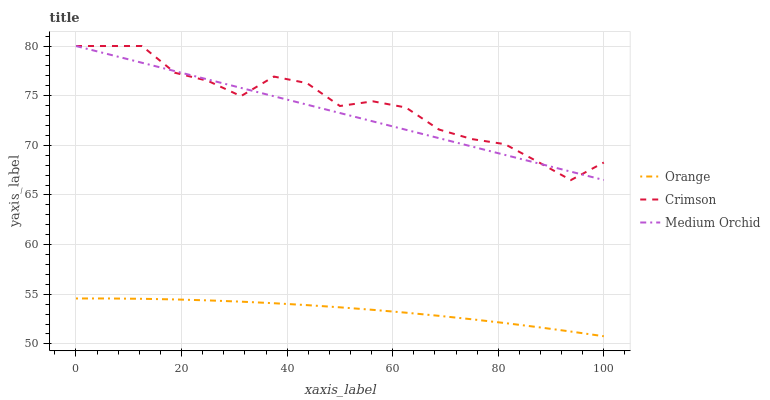Does Orange have the minimum area under the curve?
Answer yes or no. Yes. Does Crimson have the maximum area under the curve?
Answer yes or no. Yes. Does Medium Orchid have the minimum area under the curve?
Answer yes or no. No. Does Medium Orchid have the maximum area under the curve?
Answer yes or no. No. Is Medium Orchid the smoothest?
Answer yes or no. Yes. Is Crimson the roughest?
Answer yes or no. Yes. Is Crimson the smoothest?
Answer yes or no. No. Is Medium Orchid the roughest?
Answer yes or no. No. Does Orange have the lowest value?
Answer yes or no. Yes. Does Crimson have the lowest value?
Answer yes or no. No. Does Medium Orchid have the highest value?
Answer yes or no. Yes. Is Orange less than Medium Orchid?
Answer yes or no. Yes. Is Medium Orchid greater than Orange?
Answer yes or no. Yes. Does Crimson intersect Medium Orchid?
Answer yes or no. Yes. Is Crimson less than Medium Orchid?
Answer yes or no. No. Is Crimson greater than Medium Orchid?
Answer yes or no. No. Does Orange intersect Medium Orchid?
Answer yes or no. No. 